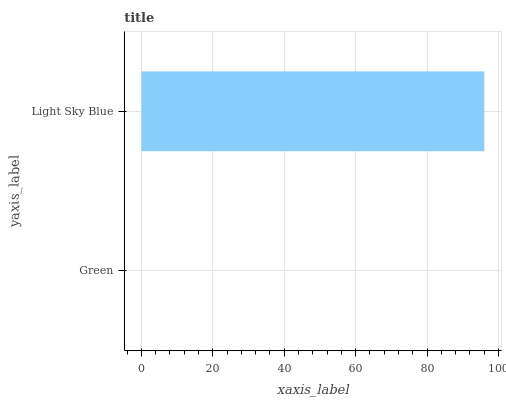Is Green the minimum?
Answer yes or no. Yes. Is Light Sky Blue the maximum?
Answer yes or no. Yes. Is Light Sky Blue the minimum?
Answer yes or no. No. Is Light Sky Blue greater than Green?
Answer yes or no. Yes. Is Green less than Light Sky Blue?
Answer yes or no. Yes. Is Green greater than Light Sky Blue?
Answer yes or no. No. Is Light Sky Blue less than Green?
Answer yes or no. No. Is Light Sky Blue the high median?
Answer yes or no. Yes. Is Green the low median?
Answer yes or no. Yes. Is Green the high median?
Answer yes or no. No. Is Light Sky Blue the low median?
Answer yes or no. No. 